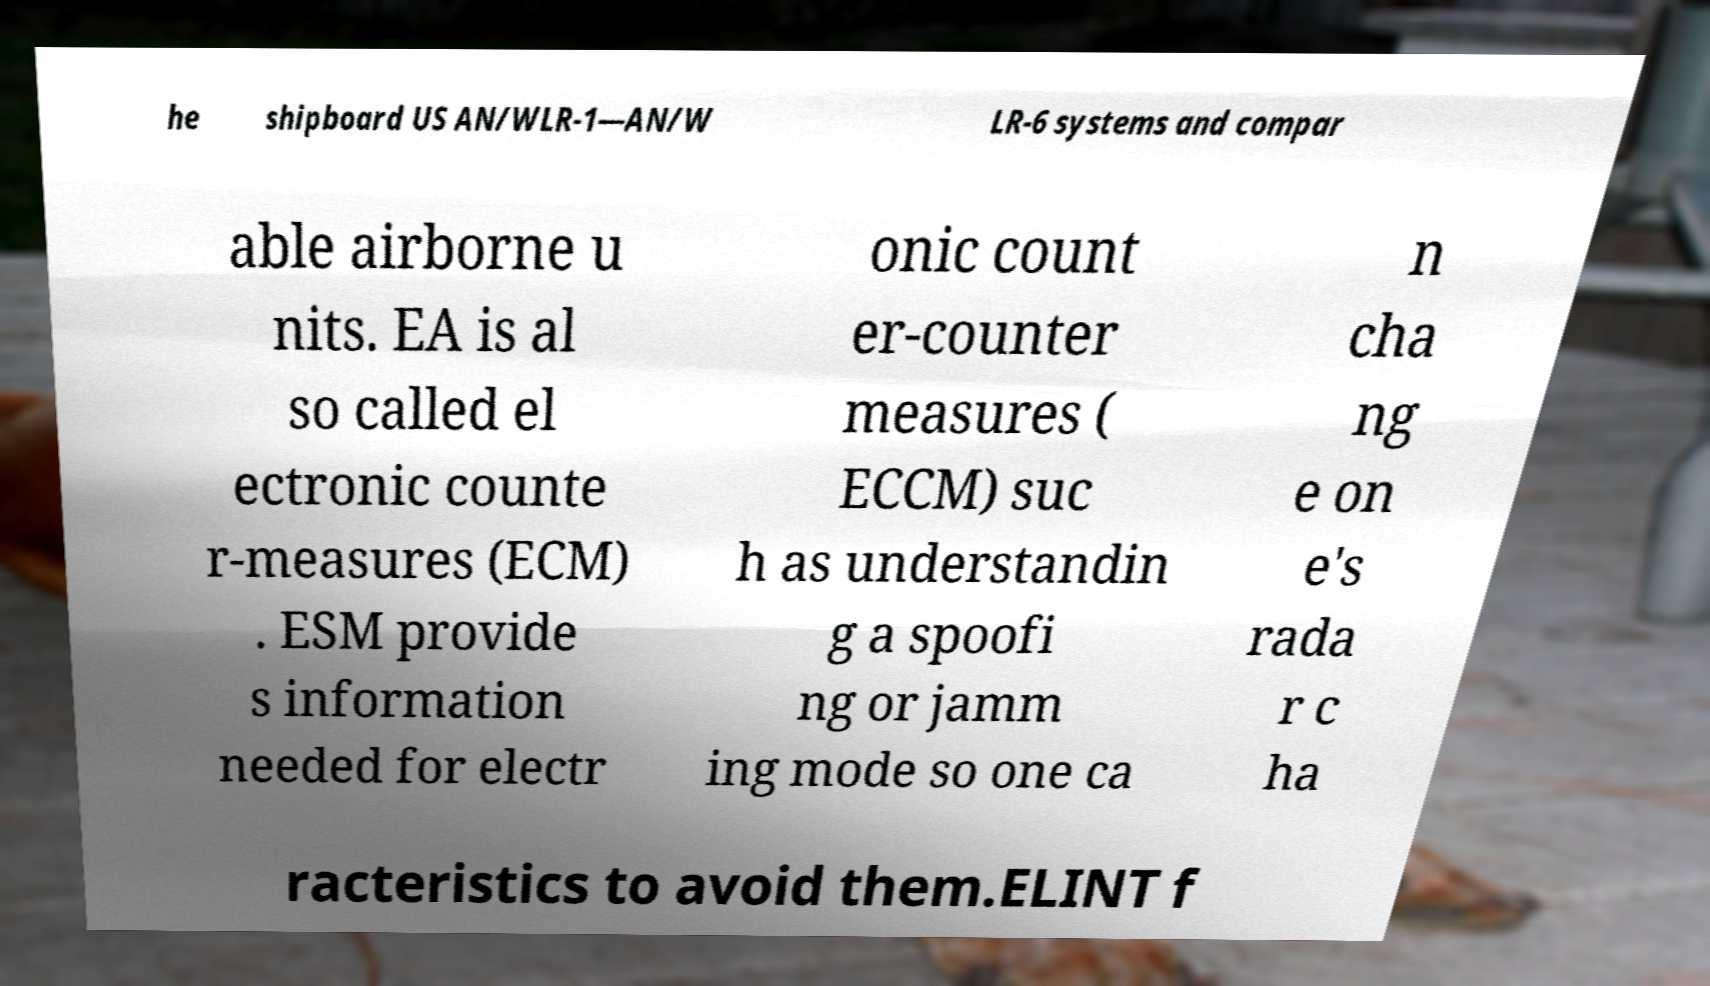Could you assist in decoding the text presented in this image and type it out clearly? he shipboard US AN/WLR-1—AN/W LR-6 systems and compar able airborne u nits. EA is al so called el ectronic counte r-measures (ECM) . ESM provide s information needed for electr onic count er-counter measures ( ECCM) suc h as understandin g a spoofi ng or jamm ing mode so one ca n cha ng e on e's rada r c ha racteristics to avoid them.ELINT f 